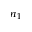Convert formula to latex. <formula><loc_0><loc_0><loc_500><loc_500>n _ { 1 }</formula> 